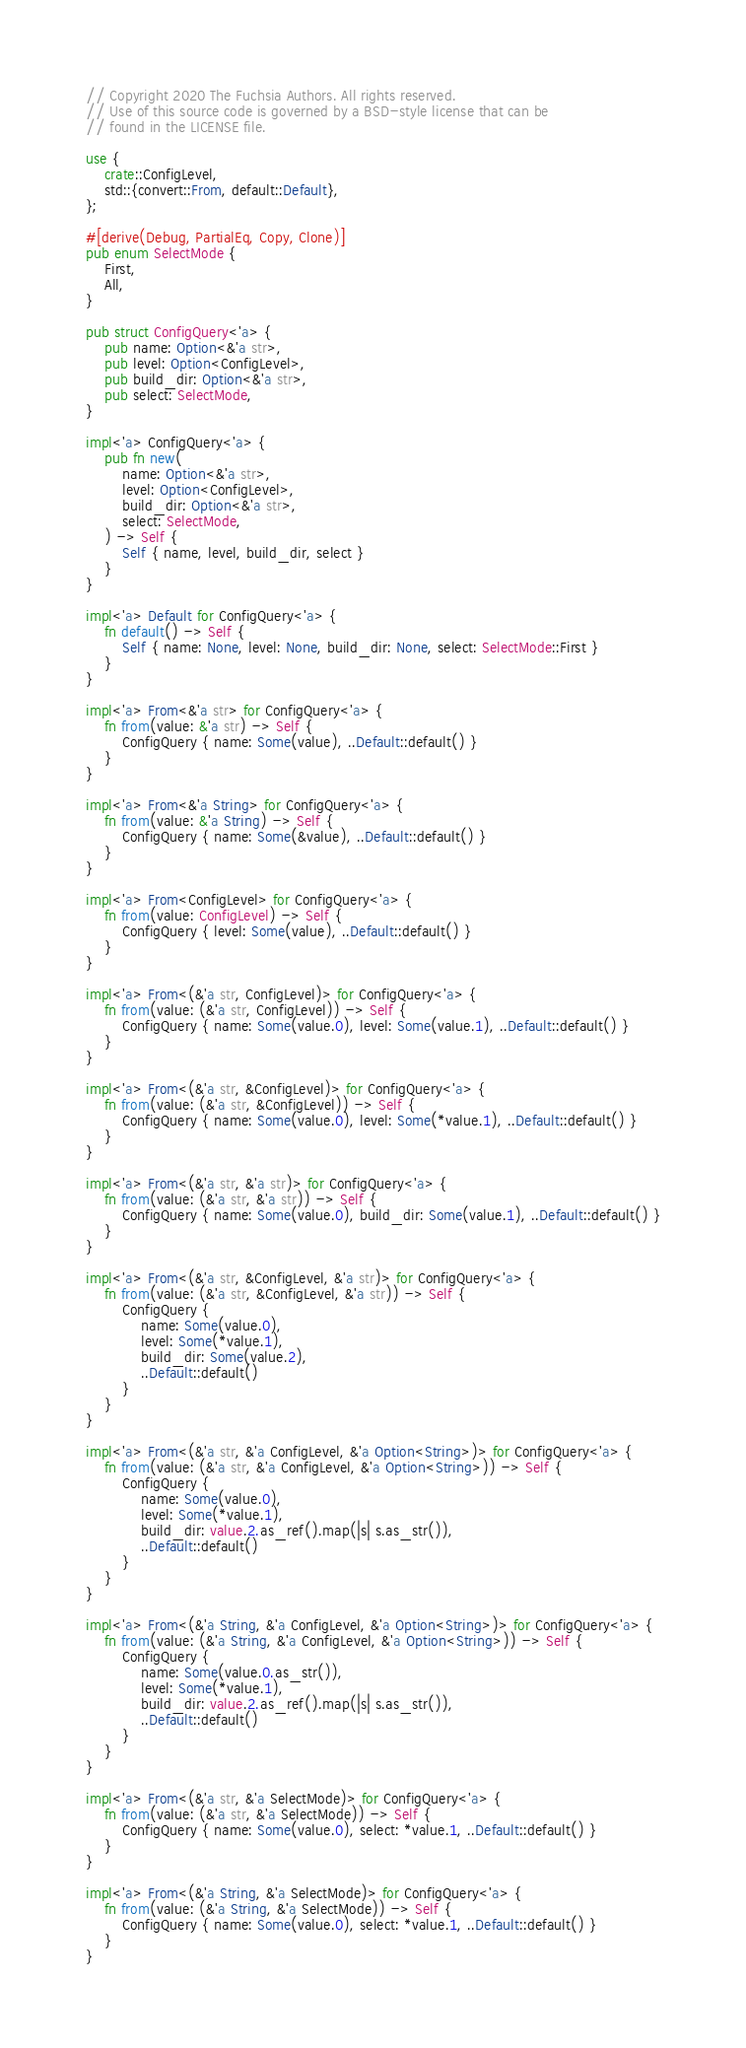<code> <loc_0><loc_0><loc_500><loc_500><_Rust_>// Copyright 2020 The Fuchsia Authors. All rights reserved.
// Use of this source code is governed by a BSD-style license that can be
// found in the LICENSE file.

use {
    crate::ConfigLevel,
    std::{convert::From, default::Default},
};

#[derive(Debug, PartialEq, Copy, Clone)]
pub enum SelectMode {
    First,
    All,
}

pub struct ConfigQuery<'a> {
    pub name: Option<&'a str>,
    pub level: Option<ConfigLevel>,
    pub build_dir: Option<&'a str>,
    pub select: SelectMode,
}

impl<'a> ConfigQuery<'a> {
    pub fn new(
        name: Option<&'a str>,
        level: Option<ConfigLevel>,
        build_dir: Option<&'a str>,
        select: SelectMode,
    ) -> Self {
        Self { name, level, build_dir, select }
    }
}

impl<'a> Default for ConfigQuery<'a> {
    fn default() -> Self {
        Self { name: None, level: None, build_dir: None, select: SelectMode::First }
    }
}

impl<'a> From<&'a str> for ConfigQuery<'a> {
    fn from(value: &'a str) -> Self {
        ConfigQuery { name: Some(value), ..Default::default() }
    }
}

impl<'a> From<&'a String> for ConfigQuery<'a> {
    fn from(value: &'a String) -> Self {
        ConfigQuery { name: Some(&value), ..Default::default() }
    }
}

impl<'a> From<ConfigLevel> for ConfigQuery<'a> {
    fn from(value: ConfigLevel) -> Self {
        ConfigQuery { level: Some(value), ..Default::default() }
    }
}

impl<'a> From<(&'a str, ConfigLevel)> for ConfigQuery<'a> {
    fn from(value: (&'a str, ConfigLevel)) -> Self {
        ConfigQuery { name: Some(value.0), level: Some(value.1), ..Default::default() }
    }
}

impl<'a> From<(&'a str, &ConfigLevel)> for ConfigQuery<'a> {
    fn from(value: (&'a str, &ConfigLevel)) -> Self {
        ConfigQuery { name: Some(value.0), level: Some(*value.1), ..Default::default() }
    }
}

impl<'a> From<(&'a str, &'a str)> for ConfigQuery<'a> {
    fn from(value: (&'a str, &'a str)) -> Self {
        ConfigQuery { name: Some(value.0), build_dir: Some(value.1), ..Default::default() }
    }
}

impl<'a> From<(&'a str, &ConfigLevel, &'a str)> for ConfigQuery<'a> {
    fn from(value: (&'a str, &ConfigLevel, &'a str)) -> Self {
        ConfigQuery {
            name: Some(value.0),
            level: Some(*value.1),
            build_dir: Some(value.2),
            ..Default::default()
        }
    }
}

impl<'a> From<(&'a str, &'a ConfigLevel, &'a Option<String>)> for ConfigQuery<'a> {
    fn from(value: (&'a str, &'a ConfigLevel, &'a Option<String>)) -> Self {
        ConfigQuery {
            name: Some(value.0),
            level: Some(*value.1),
            build_dir: value.2.as_ref().map(|s| s.as_str()),
            ..Default::default()
        }
    }
}

impl<'a> From<(&'a String, &'a ConfigLevel, &'a Option<String>)> for ConfigQuery<'a> {
    fn from(value: (&'a String, &'a ConfigLevel, &'a Option<String>)) -> Self {
        ConfigQuery {
            name: Some(value.0.as_str()),
            level: Some(*value.1),
            build_dir: value.2.as_ref().map(|s| s.as_str()),
            ..Default::default()
        }
    }
}

impl<'a> From<(&'a str, &'a SelectMode)> for ConfigQuery<'a> {
    fn from(value: (&'a str, &'a SelectMode)) -> Self {
        ConfigQuery { name: Some(value.0), select: *value.1, ..Default::default() }
    }
}

impl<'a> From<(&'a String, &'a SelectMode)> for ConfigQuery<'a> {
    fn from(value: (&'a String, &'a SelectMode)) -> Self {
        ConfigQuery { name: Some(value.0), select: *value.1, ..Default::default() }
    }
}
</code> 